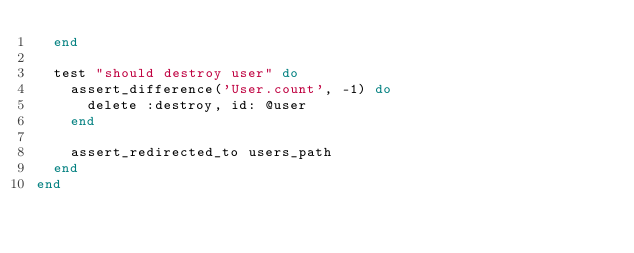Convert code to text. <code><loc_0><loc_0><loc_500><loc_500><_Ruby_>  end

  test "should destroy user" do
    assert_difference('User.count', -1) do
      delete :destroy, id: @user
    end

    assert_redirected_to users_path
  end
end
</code> 